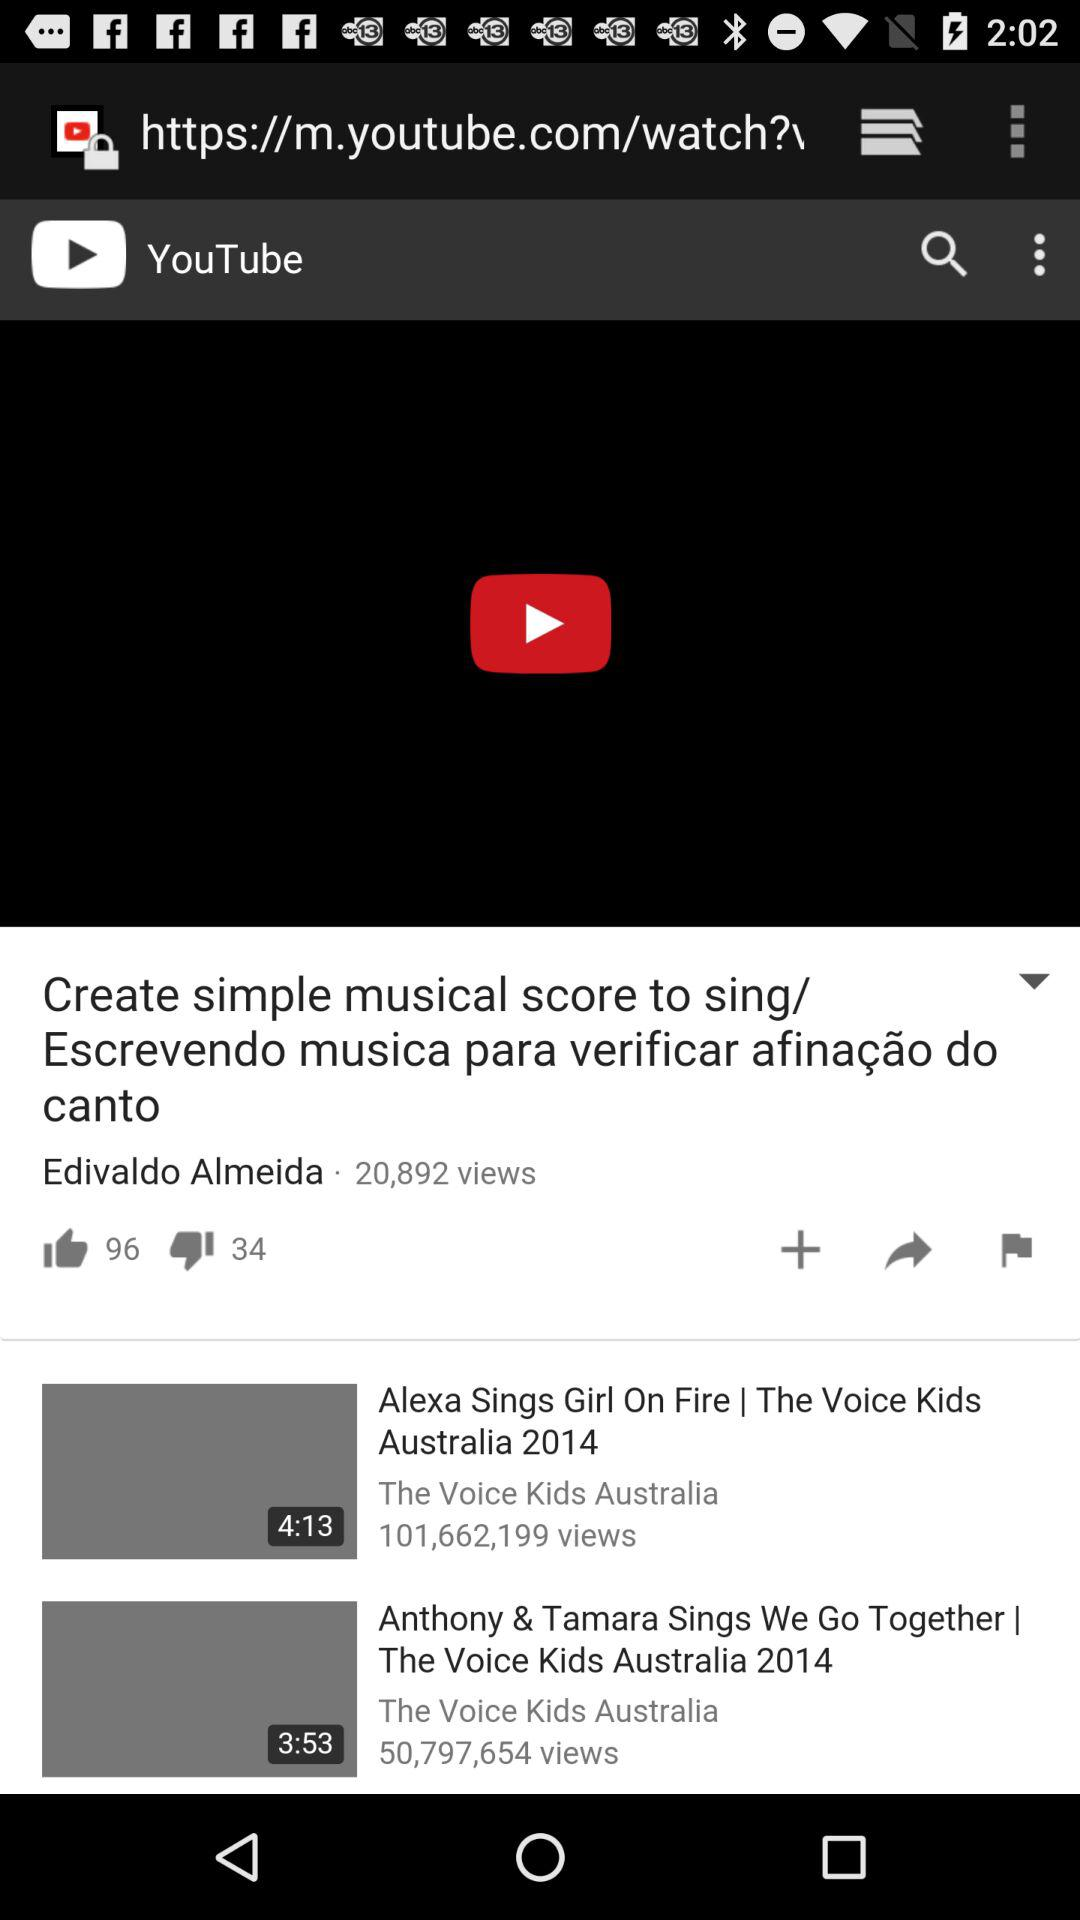How many likes are there for the video "Create simple musical score to sing/ Escrevendo musica para verificar afinação do canto"? There are 96 likes. 